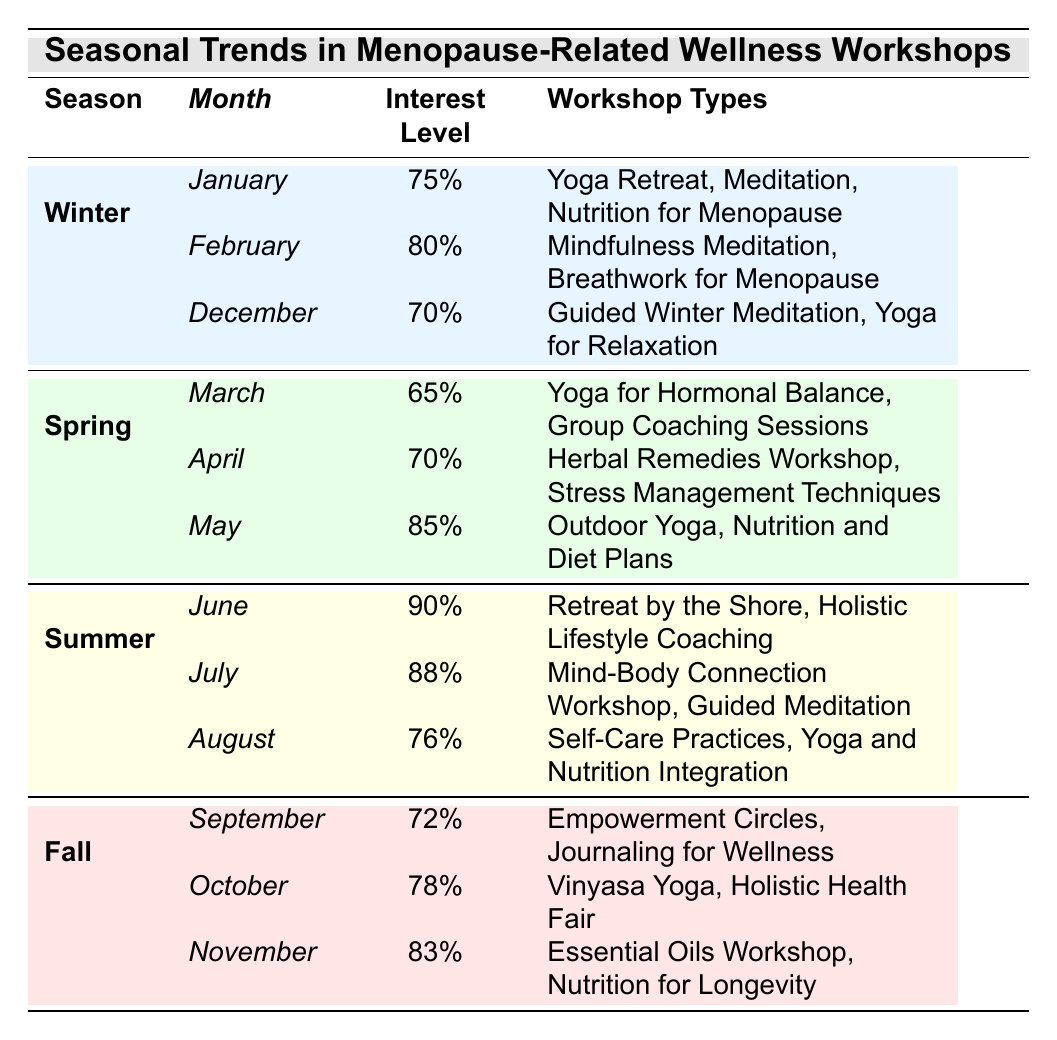What's the interest level for Yoga Retreat in January? The table shows that in January, under the Winter season, the interest level for the Yoga Retreat is 75%.
Answer: 75% Which month has the highest interest level? By examining the interest levels listed for each month, June has the highest interest level at 90%.
Answer: June How many workshop types are listed for the Spring season? In the Spring season (March, April, May), there are a total of 3 workshop types listed in March, 2 in April, and 2 in May. Adding these gives 3 + 2 + 2 = 7 workshop types.
Answer: 7 Do any months in Summer have an interest level below 80%? The interest levels for June, July, and August in the Summer season are 90%, 88%, and 76%, respectively. Since August has an interest level of 76%, the answer is yes.
Answer: Yes What is the average interest level for the Winter months? The interest levels for the Winter months (January 75%, February 80%, December 70%) sum up to 75 + 80 + 70 = 225. Dividing by the number of Winter months (3) gives an average of 225/3 = 75%.
Answer: 75% Which workshop type had the highest interest level in Summer? The workshop type with the highest interest level in Summer is the "Retreat by the Shore," with a level of 90% in June.
Answer: Retreat by the Shore How does the interest level in March compare to April? The interest level in March is 65%, while in April it is 70%. Since 70% is greater than 65%, it shows that the interest level increased from March to April.
Answer: Increased Which season has the lowest average interest level across its months? Assessing the average interest levels, Winter (75, 80, 70) gives an average of 75%, Spring (65, 70, 85) gives 73.33%, Summer (90, 88, 76) yields 84.67%, and Fall (72, 78, 83) gives 77.67%. The lowest average is Spring at 73.33%.
Answer: Spring Is there a month in Fall with an interest level of 75% or greater? In the Fall months, the interest levels are 72%, 78%, and 83%. Since October (78%) and November (83%) both exceed 75%, the answer is yes.
Answer: Yes What is the total interest level across all Fall workshops? The interest levels for Fall (September 72, October 78, November 83) add up to 72 + 78 + 83 = 233.
Answer: 233 